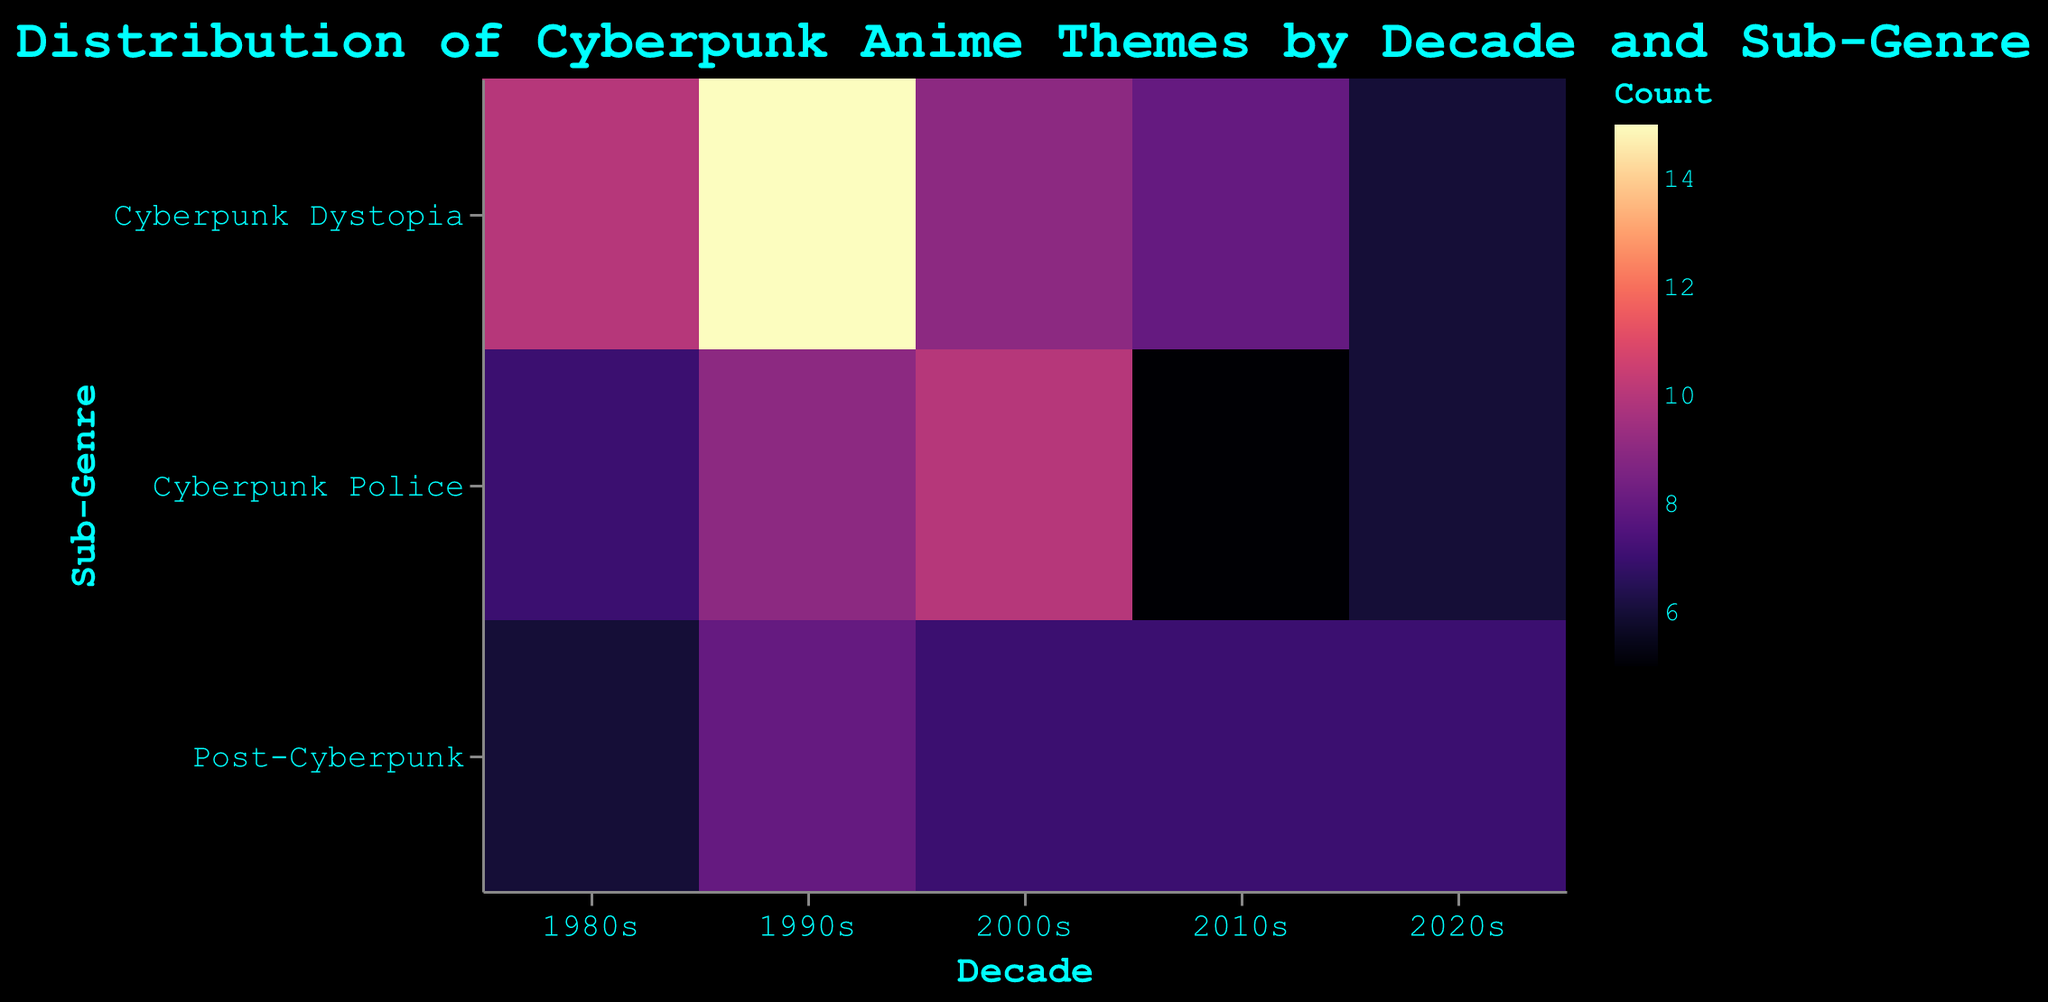What is the title of the heatmap? The title is usually placed at the top of the figure in a larger font size. Here, it reads "Distribution of Cyberpunk Anime Themes by Decade and Sub-Genre".
Answer: Distribution of Cyberpunk Anime Themes by Decade and Sub-Genre Which sub-genre has the highest count of series in the 1980s? To find this, look at the corresponding squares in the 1980s column and compare their color intensity. The square with the highest color intensity represents the highest count. "Cyberpunk Dystopia" has the square with the most intense color.
Answer: Cyberpunk Dystopia Does the count of Cyberpunk Dystopia series increase or decrease over the decades? Look at the "Cyberpunk Dystopia" row across the different decades and compare the color intensity of each square. The counts are 10 (1980s), 15 (1990s), 9 (2000s), 8 (2010s), and 6 (2020s). Overall, it first increases and then decreases.
Answer: Increases then decreases Which decade shows the most even distribution across all sub-genres? Examine the color intensities across each decade's column. The decade where the colors are most similar in intensity across the rows shows the most even distribution. The 2020s has relatively similar counts for all sub-genres: 6, 6, and 7.
Answer: 2020s Which series has the highest count in the 1990s? Identify the most intense color in the 1990s column, then check its tooltip for the series name. The most intense color corresponds to "Ghost in the Shell" with a count of 15.
Answer: Ghost in the Shell What is the sum of counts for Post-Cyberpunk series across all decades? Add the counts for "Post-Cyberpunk" in each decade: 6 (1980s), 8 (1990s), 7 (2000s), 7 (2010s), and 7 (2020s). The sum is 6 + 8 + 7 + 7 + 7.
Answer: 35 Is the count of Psycho-Pass higher in the 2000s or Psycho-Pass 2 in the 2010s? Compare the color intensities for "Cyberpunk Police" in the 2000s and 2010s columns. The tooltip shows Psycho-Pass has a count of 10 in the 2000s, while Psycho-Pass 2 has 5 in the 2010s.
Answer: 2000s Which decade has the least representation for Cyberpunk Police series? Look for the decade with the least intense color in the "Cyberpunk Police" row. The 2010s have a count of 5, which is the lowest.
Answer: 2010s What is the median count for series in the 1990s across all sub-genres? List the counts in the 1990s: 15 (Cyberpunk Dystopia), 9 (Cyberpunk Police), and 8 (Post-Cyberpunk). The median is the middle value in this sorted list.
Answer: 9 